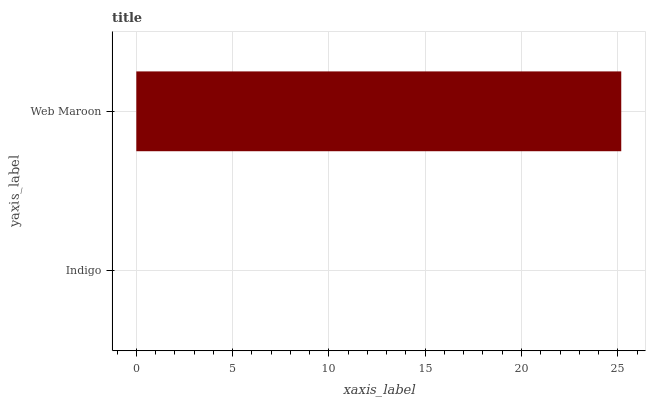Is Indigo the minimum?
Answer yes or no. Yes. Is Web Maroon the maximum?
Answer yes or no. Yes. Is Web Maroon the minimum?
Answer yes or no. No. Is Web Maroon greater than Indigo?
Answer yes or no. Yes. Is Indigo less than Web Maroon?
Answer yes or no. Yes. Is Indigo greater than Web Maroon?
Answer yes or no. No. Is Web Maroon less than Indigo?
Answer yes or no. No. Is Web Maroon the high median?
Answer yes or no. Yes. Is Indigo the low median?
Answer yes or no. Yes. Is Indigo the high median?
Answer yes or no. No. Is Web Maroon the low median?
Answer yes or no. No. 